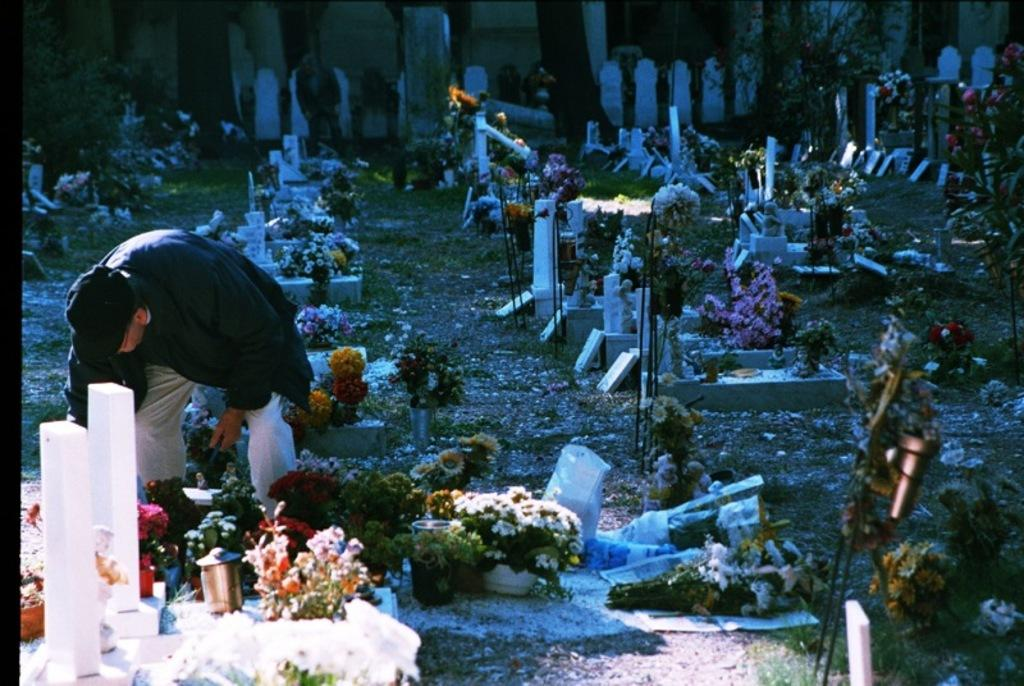What is the main setting of the image? The image depicts a graveyard. What can be seen on the graves in the image? There are flowers and candles on the graves in the image. What is the man on the left side of the image doing? The man is bending towards the ground on the left side of the image. What type of secretary can be seen working in the image? There is no secretary present in the image; it depicts a graveyard with flowers, candles, and a man bending towards the ground. How many clouds are visible in the image? The provided facts do not mention any clouds in the image, so it is impossible to determine their number. 